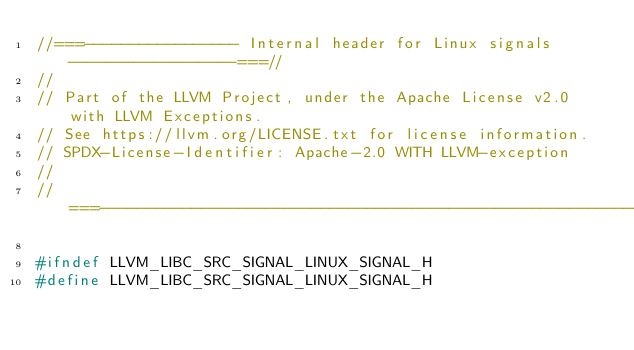<code> <loc_0><loc_0><loc_500><loc_500><_C_>//===----------------- Internal header for Linux signals ------------------===//
//
// Part of the LLVM Project, under the Apache License v2.0 with LLVM Exceptions.
// See https://llvm.org/LICENSE.txt for license information.
// SPDX-License-Identifier: Apache-2.0 WITH LLVM-exception
//
//===----------------------------------------------------------------------===//

#ifndef LLVM_LIBC_SRC_SIGNAL_LINUX_SIGNAL_H
#define LLVM_LIBC_SRC_SIGNAL_LINUX_SIGNAL_H
</code> 